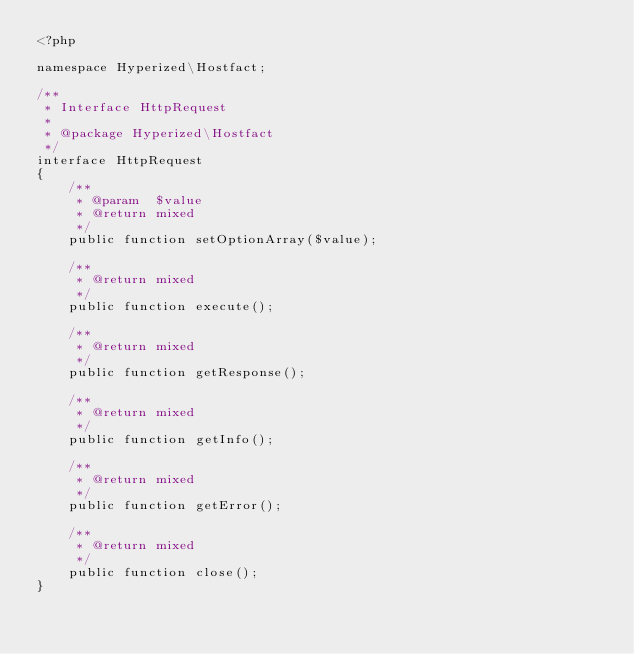Convert code to text. <code><loc_0><loc_0><loc_500><loc_500><_PHP_><?php

namespace Hyperized\Hostfact;

/**
 * Interface HttpRequest
 *
 * @package Hyperized\Hostfact
 */
interface HttpRequest
{
    /**
     * @param  $value
     * @return mixed
     */
    public function setOptionArray($value);

    /**
     * @return mixed
     */
    public function execute();

    /**
     * @return mixed
     */
    public function getResponse();

    /**
     * @return mixed
     */
    public function getInfo();

    /**
     * @return mixed
     */
    public function getError();

    /**
     * @return mixed
     */
    public function close();
}
</code> 